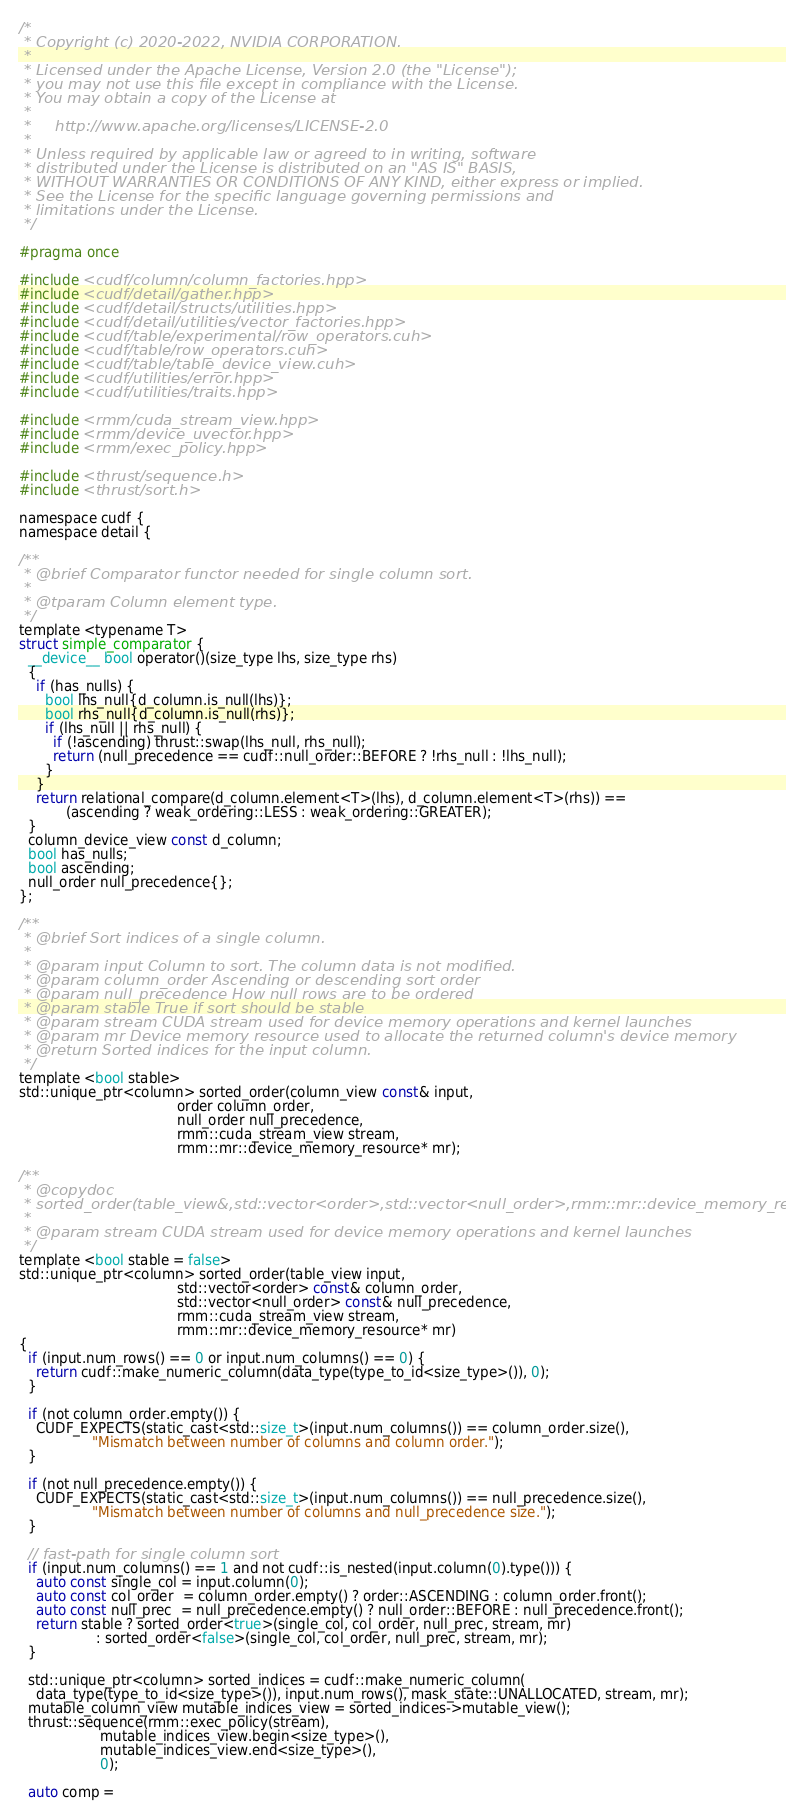<code> <loc_0><loc_0><loc_500><loc_500><_Cuda_>/*
 * Copyright (c) 2020-2022, NVIDIA CORPORATION.
 *
 * Licensed under the Apache License, Version 2.0 (the "License");
 * you may not use this file except in compliance with the License.
 * You may obtain a copy of the License at
 *
 *     http://www.apache.org/licenses/LICENSE-2.0
 *
 * Unless required by applicable law or agreed to in writing, software
 * distributed under the License is distributed on an "AS IS" BASIS,
 * WITHOUT WARRANTIES OR CONDITIONS OF ANY KIND, either express or implied.
 * See the License for the specific language governing permissions and
 * limitations under the License.
 */

#pragma once

#include <cudf/column/column_factories.hpp>
#include <cudf/detail/gather.hpp>
#include <cudf/detail/structs/utilities.hpp>
#include <cudf/detail/utilities/vector_factories.hpp>
#include <cudf/table/experimental/row_operators.cuh>
#include <cudf/table/row_operators.cuh>
#include <cudf/table/table_device_view.cuh>
#include <cudf/utilities/error.hpp>
#include <cudf/utilities/traits.hpp>

#include <rmm/cuda_stream_view.hpp>
#include <rmm/device_uvector.hpp>
#include <rmm/exec_policy.hpp>

#include <thrust/sequence.h>
#include <thrust/sort.h>

namespace cudf {
namespace detail {

/**
 * @brief Comparator functor needed for single column sort.
 *
 * @tparam Column element type.
 */
template <typename T>
struct simple_comparator {
  __device__ bool operator()(size_type lhs, size_type rhs)
  {
    if (has_nulls) {
      bool lhs_null{d_column.is_null(lhs)};
      bool rhs_null{d_column.is_null(rhs)};
      if (lhs_null || rhs_null) {
        if (!ascending) thrust::swap(lhs_null, rhs_null);
        return (null_precedence == cudf::null_order::BEFORE ? !rhs_null : !lhs_null);
      }
    }
    return relational_compare(d_column.element<T>(lhs), d_column.element<T>(rhs)) ==
           (ascending ? weak_ordering::LESS : weak_ordering::GREATER);
  }
  column_device_view const d_column;
  bool has_nulls;
  bool ascending;
  null_order null_precedence{};
};

/**
 * @brief Sort indices of a single column.
 *
 * @param input Column to sort. The column data is not modified.
 * @param column_order Ascending or descending sort order
 * @param null_precedence How null rows are to be ordered
 * @param stable True if sort should be stable
 * @param stream CUDA stream used for device memory operations and kernel launches
 * @param mr Device memory resource used to allocate the returned column's device memory
 * @return Sorted indices for the input column.
 */
template <bool stable>
std::unique_ptr<column> sorted_order(column_view const& input,
                                     order column_order,
                                     null_order null_precedence,
                                     rmm::cuda_stream_view stream,
                                     rmm::mr::device_memory_resource* mr);

/**
 * @copydoc
 * sorted_order(table_view&,std::vector<order>,std::vector<null_order>,rmm::mr::device_memory_resource*)
 *
 * @param stream CUDA stream used for device memory operations and kernel launches
 */
template <bool stable = false>
std::unique_ptr<column> sorted_order(table_view input,
                                     std::vector<order> const& column_order,
                                     std::vector<null_order> const& null_precedence,
                                     rmm::cuda_stream_view stream,
                                     rmm::mr::device_memory_resource* mr)
{
  if (input.num_rows() == 0 or input.num_columns() == 0) {
    return cudf::make_numeric_column(data_type(type_to_id<size_type>()), 0);
  }

  if (not column_order.empty()) {
    CUDF_EXPECTS(static_cast<std::size_t>(input.num_columns()) == column_order.size(),
                 "Mismatch between number of columns and column order.");
  }

  if (not null_precedence.empty()) {
    CUDF_EXPECTS(static_cast<std::size_t>(input.num_columns()) == null_precedence.size(),
                 "Mismatch between number of columns and null_precedence size.");
  }

  // fast-path for single column sort
  if (input.num_columns() == 1 and not cudf::is_nested(input.column(0).type())) {
    auto const single_col = input.column(0);
    auto const col_order  = column_order.empty() ? order::ASCENDING : column_order.front();
    auto const null_prec  = null_precedence.empty() ? null_order::BEFORE : null_precedence.front();
    return stable ? sorted_order<true>(single_col, col_order, null_prec, stream, mr)
                  : sorted_order<false>(single_col, col_order, null_prec, stream, mr);
  }

  std::unique_ptr<column> sorted_indices = cudf::make_numeric_column(
    data_type(type_to_id<size_type>()), input.num_rows(), mask_state::UNALLOCATED, stream, mr);
  mutable_column_view mutable_indices_view = sorted_indices->mutable_view();
  thrust::sequence(rmm::exec_policy(stream),
                   mutable_indices_view.begin<size_type>(),
                   mutable_indices_view.end<size_type>(),
                   0);

  auto comp =</code> 